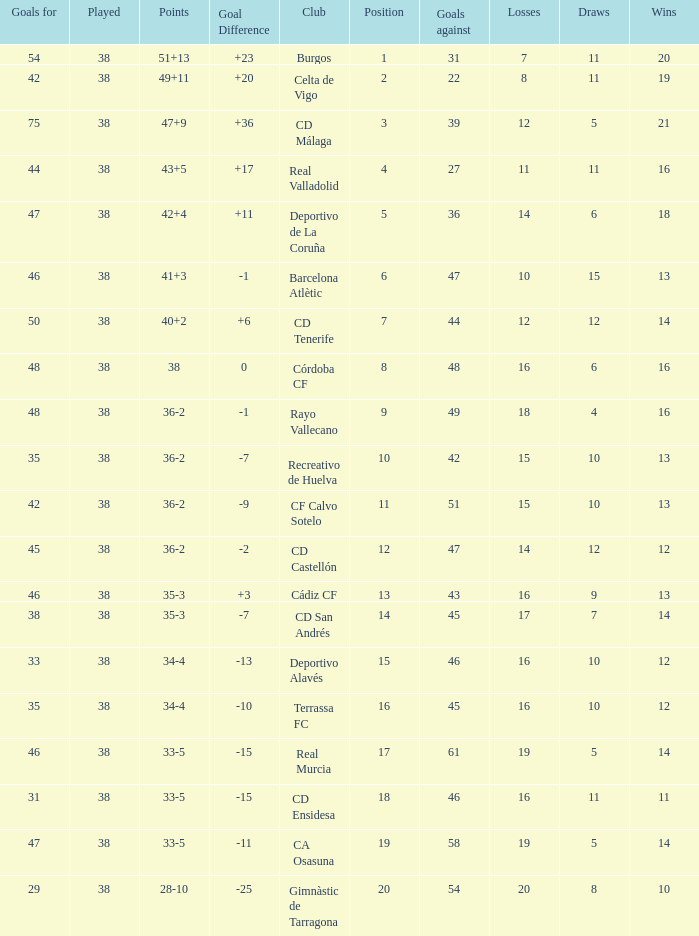Which is the lowest played with 28-10 points and goals higher than 29? None. 